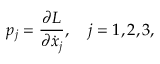Convert formula to latex. <formula><loc_0><loc_0><loc_500><loc_500>p _ { j } = { \frac { \partial L } { \partial \dot { x } _ { j } } } , \quad j = 1 , 2 , 3 ,</formula> 